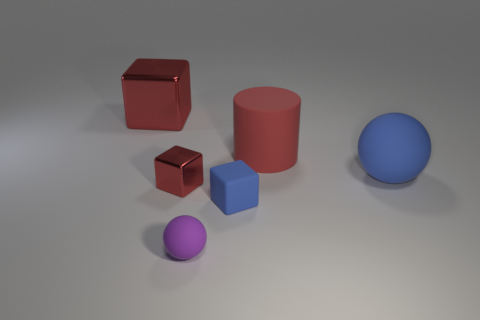Add 2 cubes. How many objects exist? 8 Subtract all spheres. How many objects are left? 4 Add 3 big metal cubes. How many big metal cubes exist? 4 Subtract 0 brown cylinders. How many objects are left? 6 Subtract all purple rubber things. Subtract all rubber cylinders. How many objects are left? 4 Add 1 small blue rubber blocks. How many small blue rubber blocks are left? 2 